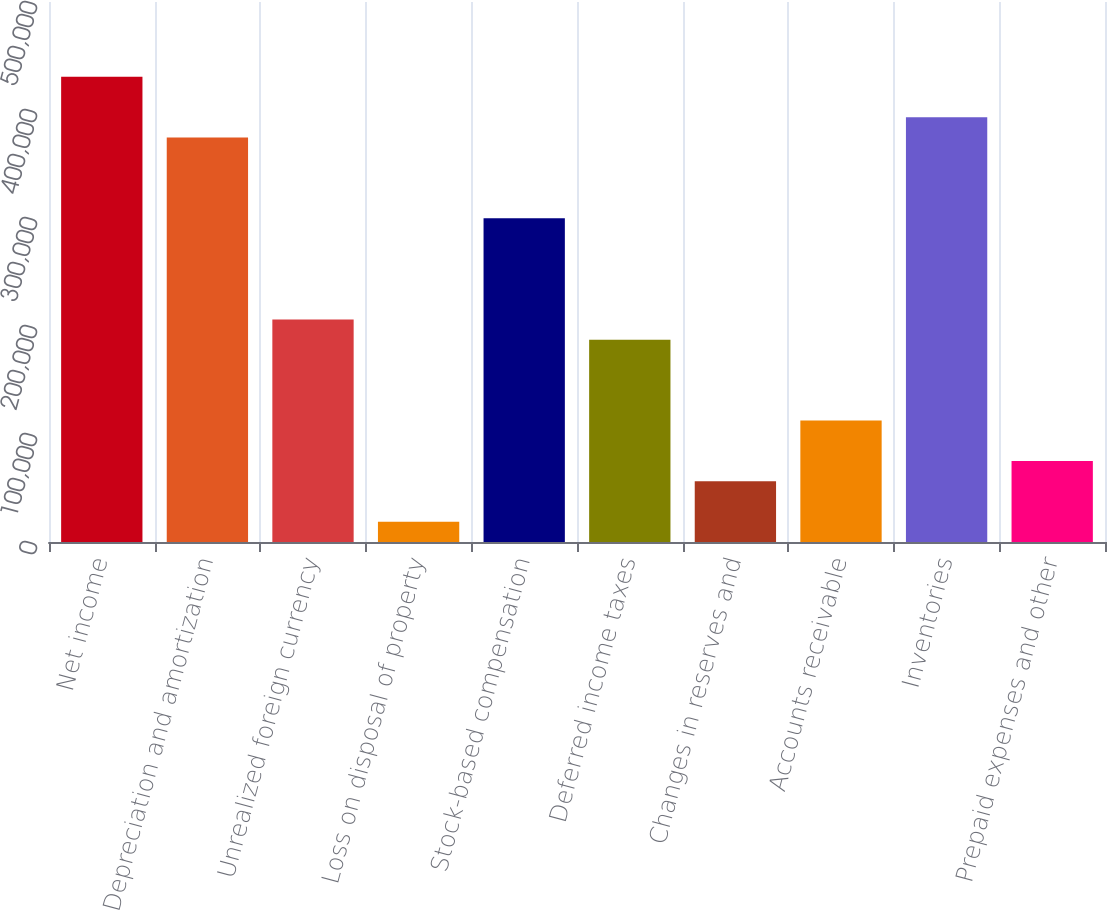Convert chart. <chart><loc_0><loc_0><loc_500><loc_500><bar_chart><fcel>Net income<fcel>Depreciation and amortization<fcel>Unrealized foreign currency<fcel>Loss on disposal of property<fcel>Stock-based compensation<fcel>Deferred income taxes<fcel>Changes in reserves and<fcel>Accounts receivable<fcel>Inventories<fcel>Prepaid expenses and other<nl><fcel>430738<fcel>374559<fcel>206023<fcel>18761.2<fcel>299654<fcel>187297<fcel>56213.6<fcel>112392<fcel>393285<fcel>74939.8<nl></chart> 